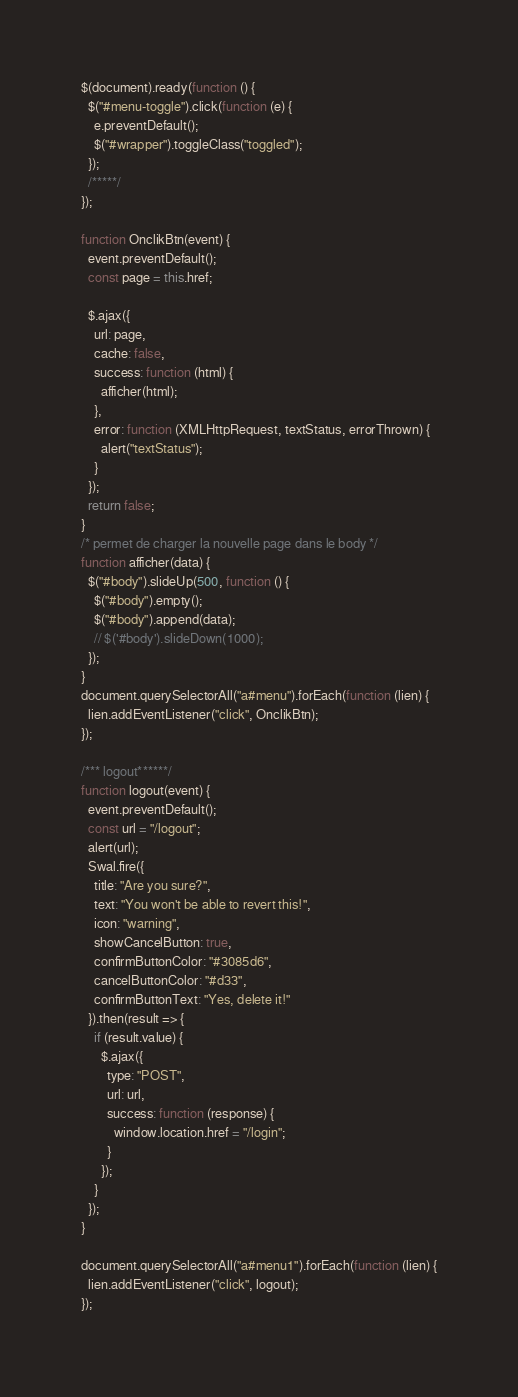<code> <loc_0><loc_0><loc_500><loc_500><_JavaScript_>$(document).ready(function () {
  $("#menu-toggle").click(function (e) {
    e.preventDefault();
    $("#wrapper").toggleClass("toggled");
  });
  /*****/
});

function OnclikBtn(event) {
  event.preventDefault();
  const page = this.href;

  $.ajax({
    url: page,
    cache: false,
    success: function (html) {
      afficher(html);
    },
    error: function (XMLHttpRequest, textStatus, errorThrown) {
      alert("textStatus");
    }
  });
  return false;
}
/* permet de charger la nouvelle page dans le body */
function afficher(data) {
  $("#body").slideUp(500, function () {
    $("#body").empty();
    $("#body").append(data);
    // $('#body').slideDown(1000);
  });
}
document.querySelectorAll("a#menu").forEach(function (lien) {
  lien.addEventListener("click", OnclikBtn);
});

/*** logout******/
function logout(event) {
  event.preventDefault();
  const url = "/logout";
  alert(url);
  Swal.fire({
    title: "Are you sure?",
    text: "You won't be able to revert this!",
    icon: "warning",
    showCancelButton: true,
    confirmButtonColor: "#3085d6",
    cancelButtonColor: "#d33",
    confirmButtonText: "Yes, delete it!"
  }).then(result => {
    if (result.value) {
      $.ajax({
        type: "POST",
        url: url,
        success: function (response) {
          window.location.href = "/login";
        }
      });
    }
  });
}

document.querySelectorAll("a#menu1").forEach(function (lien) {
  lien.addEventListener("click", logout);
});
</code> 